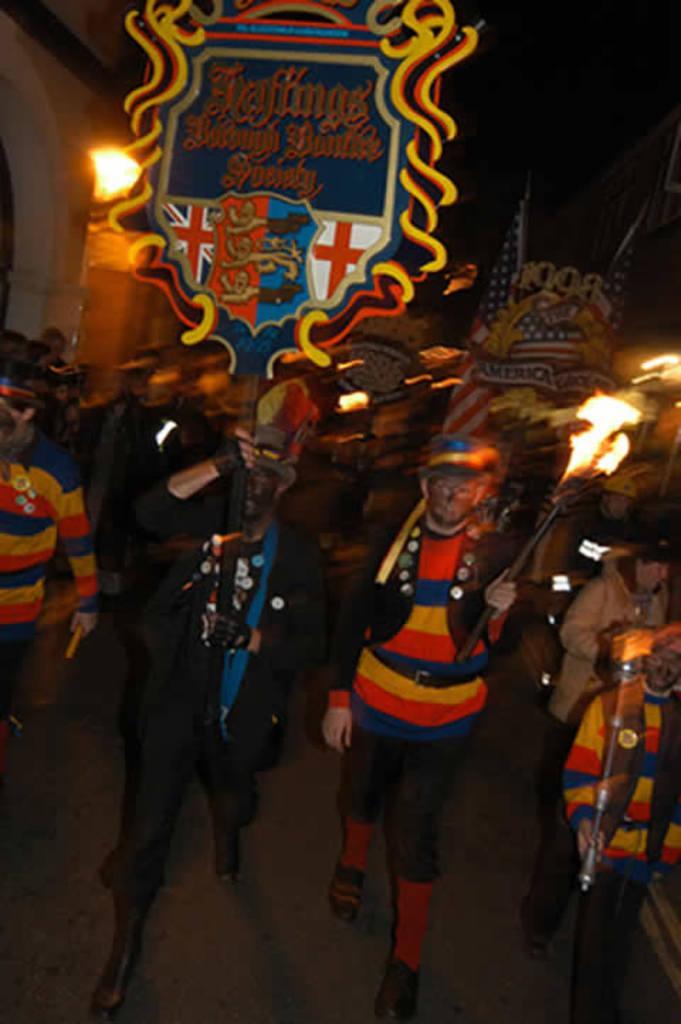Describe this image in one or two sentences. In this image I can see a crowd on the road are holding boards in their hand and lights. In the background I can see a building wall and the sky. This image is taken during night on the road. 